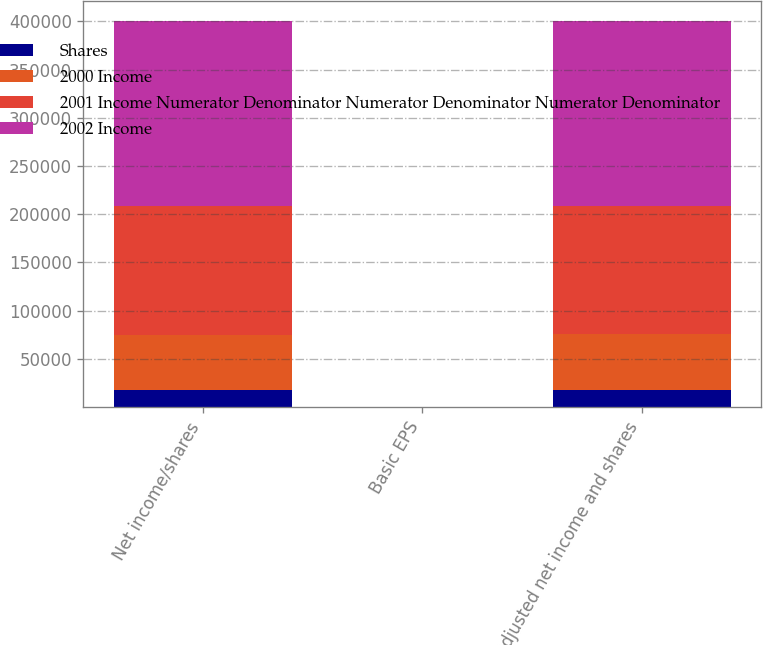Convert chart. <chart><loc_0><loc_0><loc_500><loc_500><stacked_bar_chart><ecel><fcel>Net income/shares<fcel>Basic EPS<fcel>Adjusted net income and shares<nl><fcel>Shares<fcel>17652<fcel>0.31<fcel>17652<nl><fcel>2000 Income<fcel>57196<fcel>0.31<fcel>57763<nl><fcel>2001 Income Numerator Denominator Numerator Denominator Numerator Denominator<fcel>133575<fcel>2.36<fcel>133575<nl><fcel>2002 Income<fcel>191597<fcel>3.42<fcel>191597<nl></chart> 